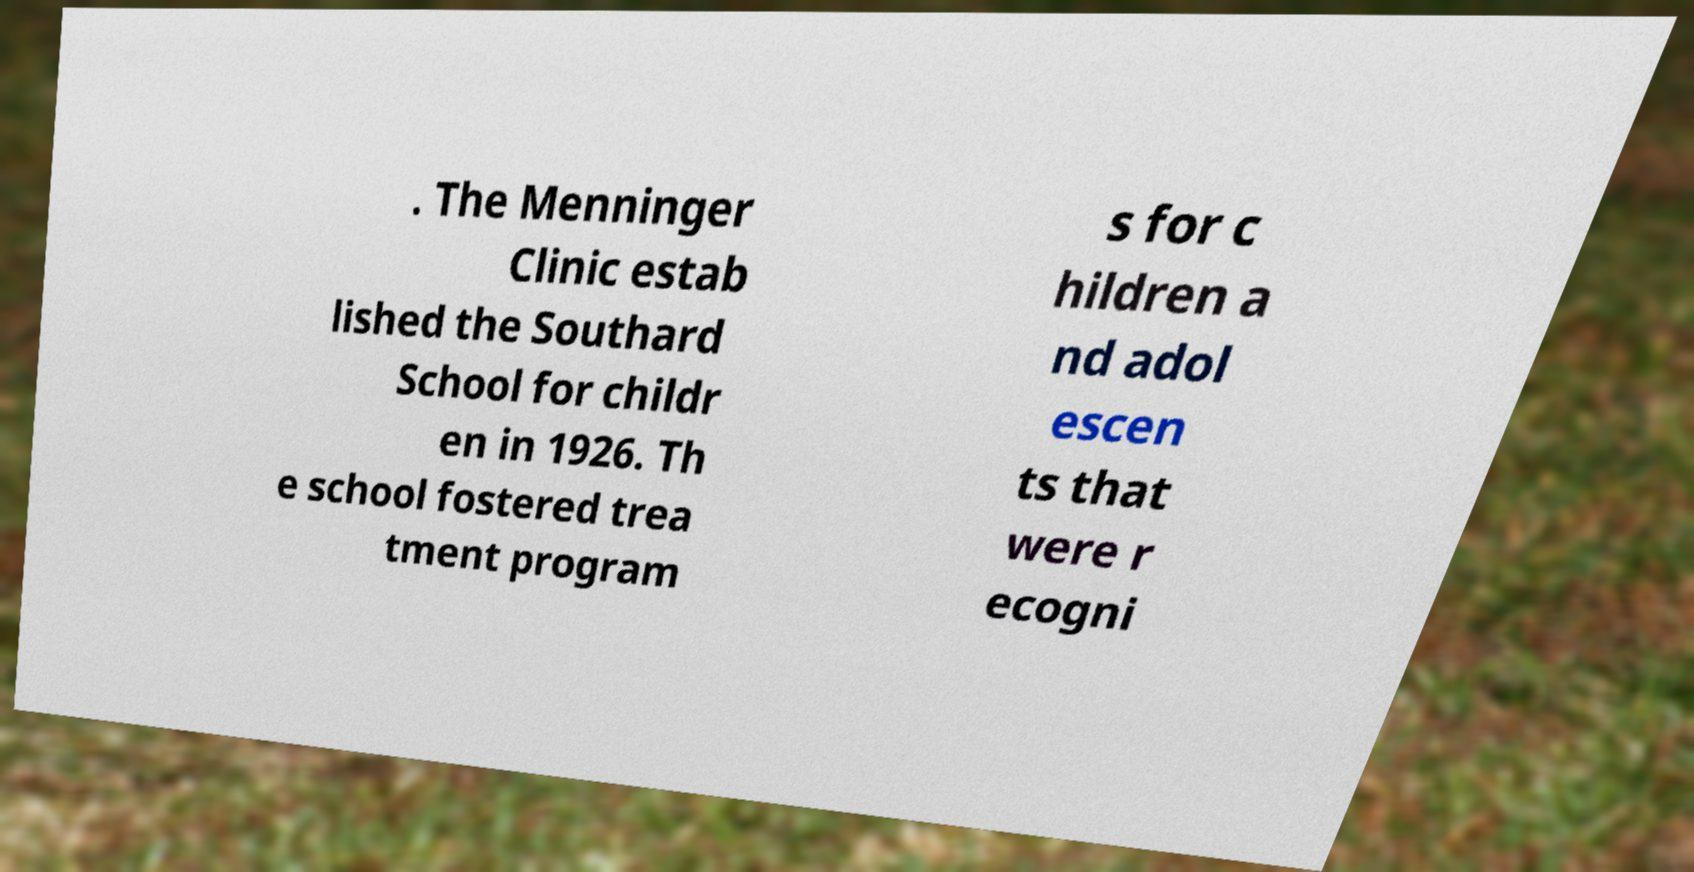Please read and relay the text visible in this image. What does it say? . The Menninger Clinic estab lished the Southard School for childr en in 1926. Th e school fostered trea tment program s for c hildren a nd adol escen ts that were r ecogni 